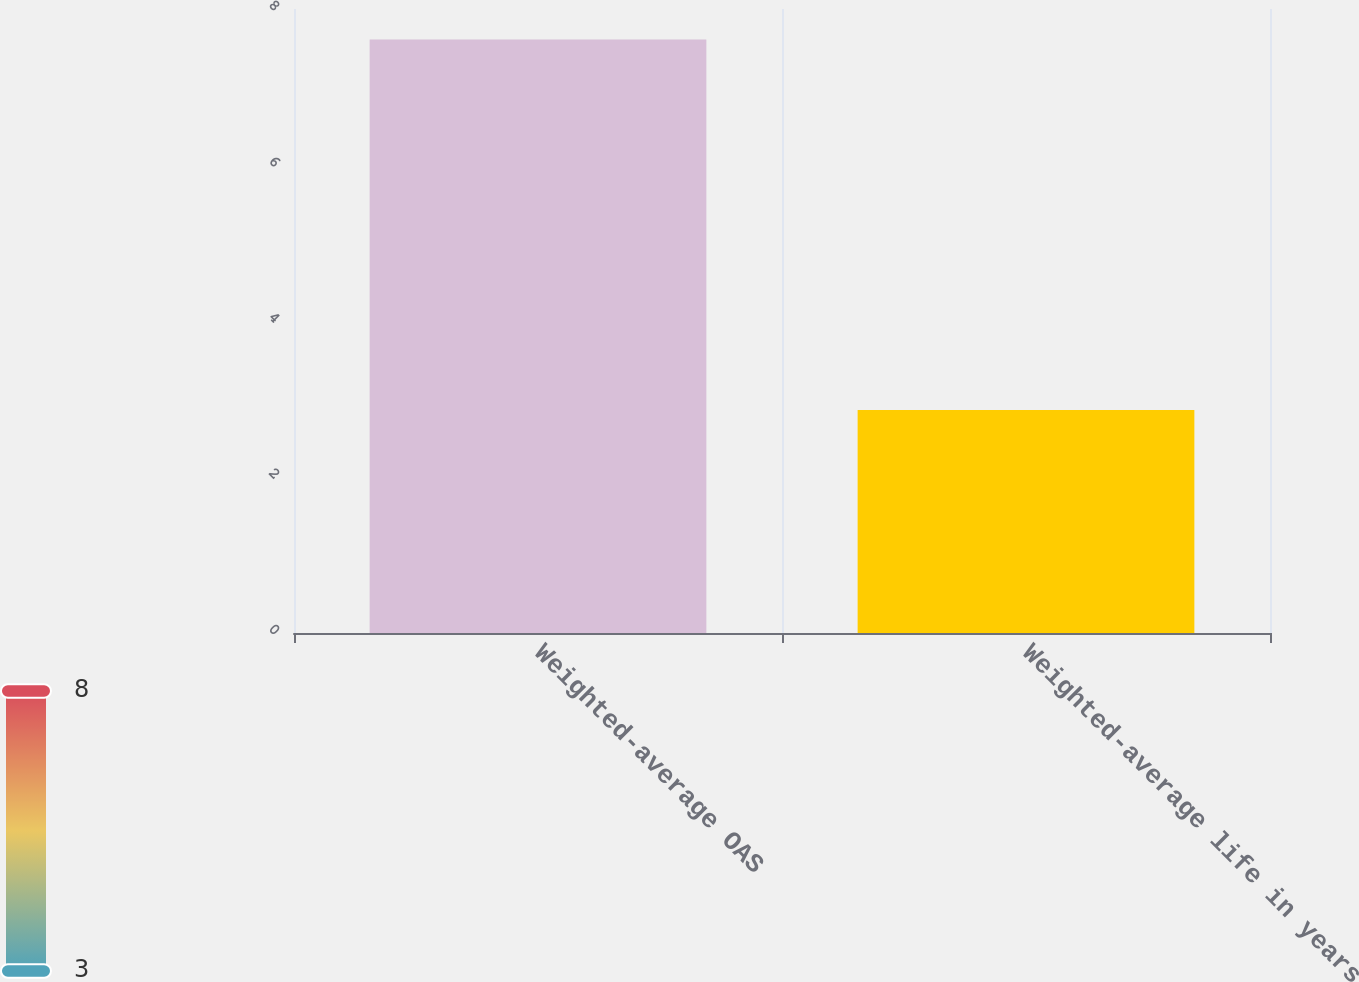Convert chart to OTSL. <chart><loc_0><loc_0><loc_500><loc_500><bar_chart><fcel>Weighted-average OAS<fcel>Weighted-average life in years<nl><fcel>7.61<fcel>2.86<nl></chart> 